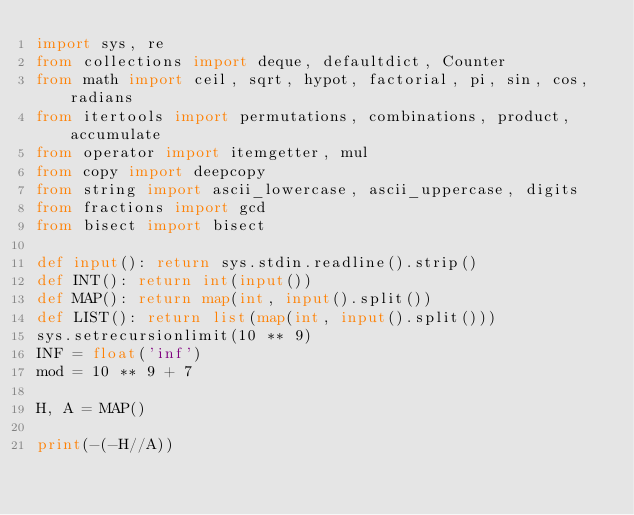<code> <loc_0><loc_0><loc_500><loc_500><_Python_>import sys, re
from collections import deque, defaultdict, Counter
from math import ceil, sqrt, hypot, factorial, pi, sin, cos, radians
from itertools import permutations, combinations, product, accumulate
from operator import itemgetter, mul
from copy import deepcopy
from string import ascii_lowercase, ascii_uppercase, digits
from fractions import gcd
from bisect import bisect

def input(): return sys.stdin.readline().strip()
def INT(): return int(input())
def MAP(): return map(int, input().split())
def LIST(): return list(map(int, input().split()))
sys.setrecursionlimit(10 ** 9)
INF = float('inf')
mod = 10 ** 9 + 7

H, A = MAP()

print(-(-H//A))
</code> 